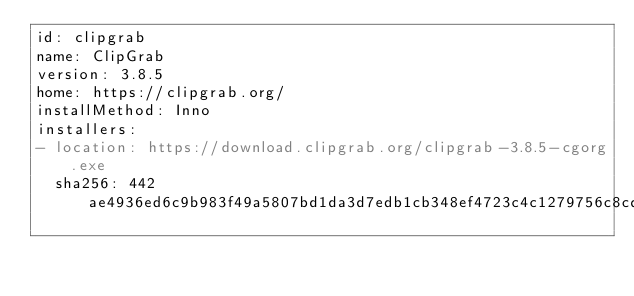Convert code to text. <code><loc_0><loc_0><loc_500><loc_500><_YAML_>id: clipgrab
name: ClipGrab
version: 3.8.5
home: https://clipgrab.org/
installMethod: Inno
installers:
- location: https://download.clipgrab.org/clipgrab-3.8.5-cgorg.exe
  sha256: 442ae4936ed6c9b983f49a5807bd1da3d7edb1cb348ef4723c4c1279756c8cdd
</code> 